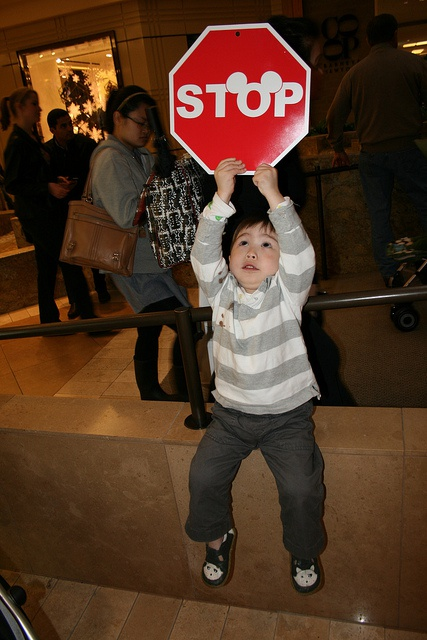Describe the objects in this image and their specific colors. I can see people in maroon, black, darkgray, lightgray, and gray tones, stop sign in maroon, brown, lightgray, and lightpink tones, people in black and maroon tones, people in maroon, black, and gray tones, and people in maroon, black, and brown tones in this image. 